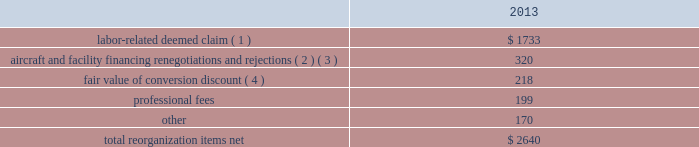Table of contents the following discussion of nonoperating income and expense excludes the results of us airways in order to provide a more meaningful year-over-year comparison .
Interest expense , net of capitalized interest decreased $ 129 million in 2014 from 2013 primarily due to a $ 63 million decrease in special charges recognized year-over-year as further described below , as well as refinancing activities that resulted in $ 65 million less interest expense recognized in 2014 .
( 1 ) in 2014 , american recognized $ 29 million of special charges relating to non-cash interest accretion on bankruptcy settlement obligations .
In 2013 , american recognized $ 48 million of special charges relating to post-petition interest expense on unsecured obligations pursuant to the plan and penalty interest related to american 2019s 10.5% ( 10.5 % ) secured notes and 7.50% ( 7.50 % ) senior secured notes .
In addition , in 2013 american recorded special charges of $ 44 million for debt extinguishment costs incurred as a result of the repayment of certain aircraft secured indebtedness , including cash interest charges and non-cash write offs of unamortized debt issuance costs .
( 2 ) as a result of the 2013 refinancing activities and the early extinguishment of american 2019s 7.50% ( 7.50 % ) senior secured notes in 2014 , american incurred $ 65 million less interest expense in 2014 as compared to 2013 .
Other nonoperating expense , net in 2014 consisted of $ 92 million of net foreign currency losses , including a $ 43 million special charge for venezuelan foreign currency losses , and $ 48 million of early debt extinguishment costs related to the prepayment of american 2019s 7.50% ( 7.50 % ) senior secured notes and other indebtedness .
The foreign currency losses were driven primarily by the strengthening of the u.s .
Dollar relative to other currencies during 2014 , principally in the latin american market , including a 48% ( 48 % ) decrease in the value of the venezuelan bolivar and a 14% ( 14 % ) decrease in the value of the brazilian real .
Other nonoperating expense , net in 2013 consisted principally of net foreign currency losses of $ 55 million and early debt extinguishment charges of $ 29 million .
Reorganization items , net reorganization items refer to revenues , expenses ( including professional fees ) , realized gains and losses and provisions for losses that are realized or incurred as a direct result of the chapter 11 cases .
The table summarizes the components included in reorganization items , net on american 2019s consolidated statement of operations for the year ended december 31 , 2013 ( in millions ) : .
( 1 ) in exchange for employees 2019 contributions to the successful reorganization , including agreeing to reductions in pay and benefits , american agreed in the plan to provide each employee group a deemed claim , which was used to provide a distribution of a portion of the equity of the reorganized entity to those employees .
Each employee group received a deemed claim amount based upon a portion of the value of cost savings provided by that group through reductions to pay and benefits as well as through certain work rule changes .
The total value of this deemed claim was approximately $ 1.7 billion .
( 2 ) amounts include allowed claims ( claims approved by the bankruptcy court ) and estimated allowed claims relating to ( i ) the rejection or modification of financings related to aircraft and ( ii ) entry of orders treated as unsecured claims with respect to facility agreements supporting certain issuances of special facility revenue .
What was the ratio of the 2014 non operating expense related to early debt extinguishment charges to 2013? 
Rationale: for every dollar spent in 2013 on early debt extinguishment charges $ 1.7 was spent in 2014
Computations: (48 / 29)
Answer: 1.65517. 